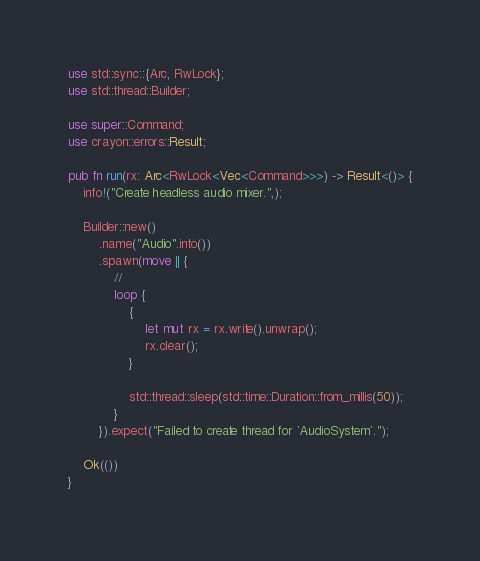<code> <loc_0><loc_0><loc_500><loc_500><_Rust_>use std::sync::{Arc, RwLock};
use std::thread::Builder;

use super::Command;
use crayon::errors::Result;

pub fn run(rx: Arc<RwLock<Vec<Command>>>) -> Result<()> {
    info!("Create headless audio mixer.",);

    Builder::new()
        .name("Audio".into())
        .spawn(move || {
            //
            loop {
                {
                    let mut rx = rx.write().unwrap();
                    rx.clear();
                }

                std::thread::sleep(std::time::Duration::from_millis(50));
            }
        }).expect("Failed to create thread for `AudioSystem`.");

    Ok(())
}
</code> 